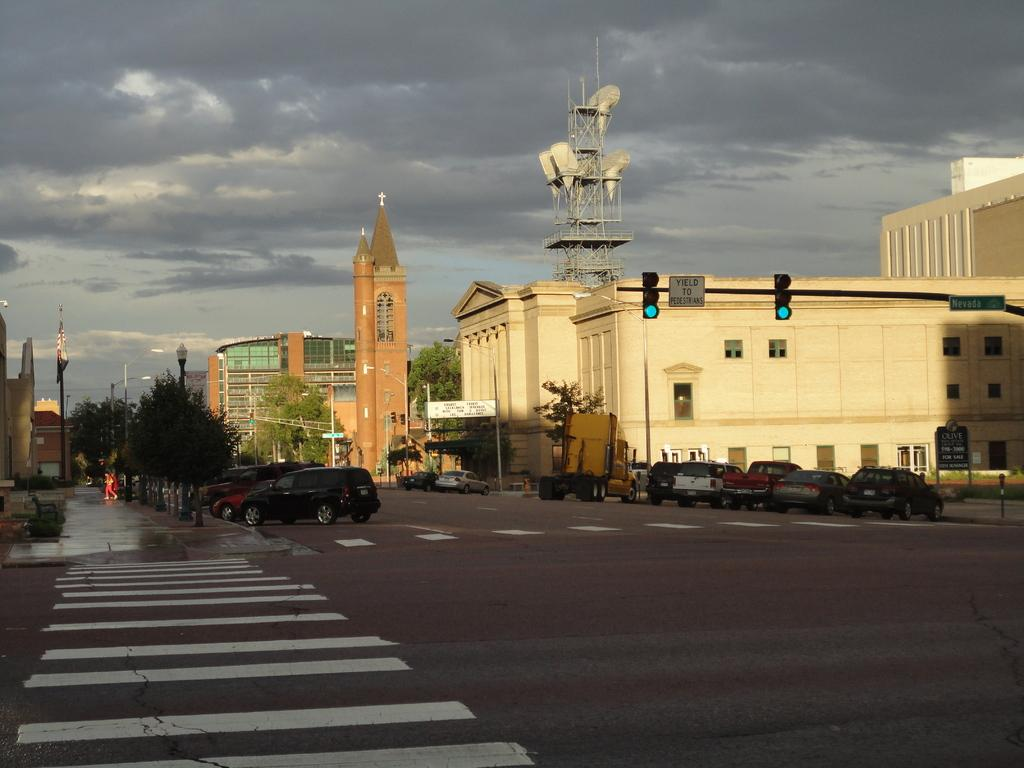What can be seen on the road in the image? There are vehicles on the road in the image. What is visible in the background of the image? In the background of the image, there are trees, poles, boards, buildings, and the sky. Can you describe the sky in the image? The sky is visible in the background of the image, and clouds are present. How many eggs are being cooked on the range in the image? There is no range or eggs present in the image. 